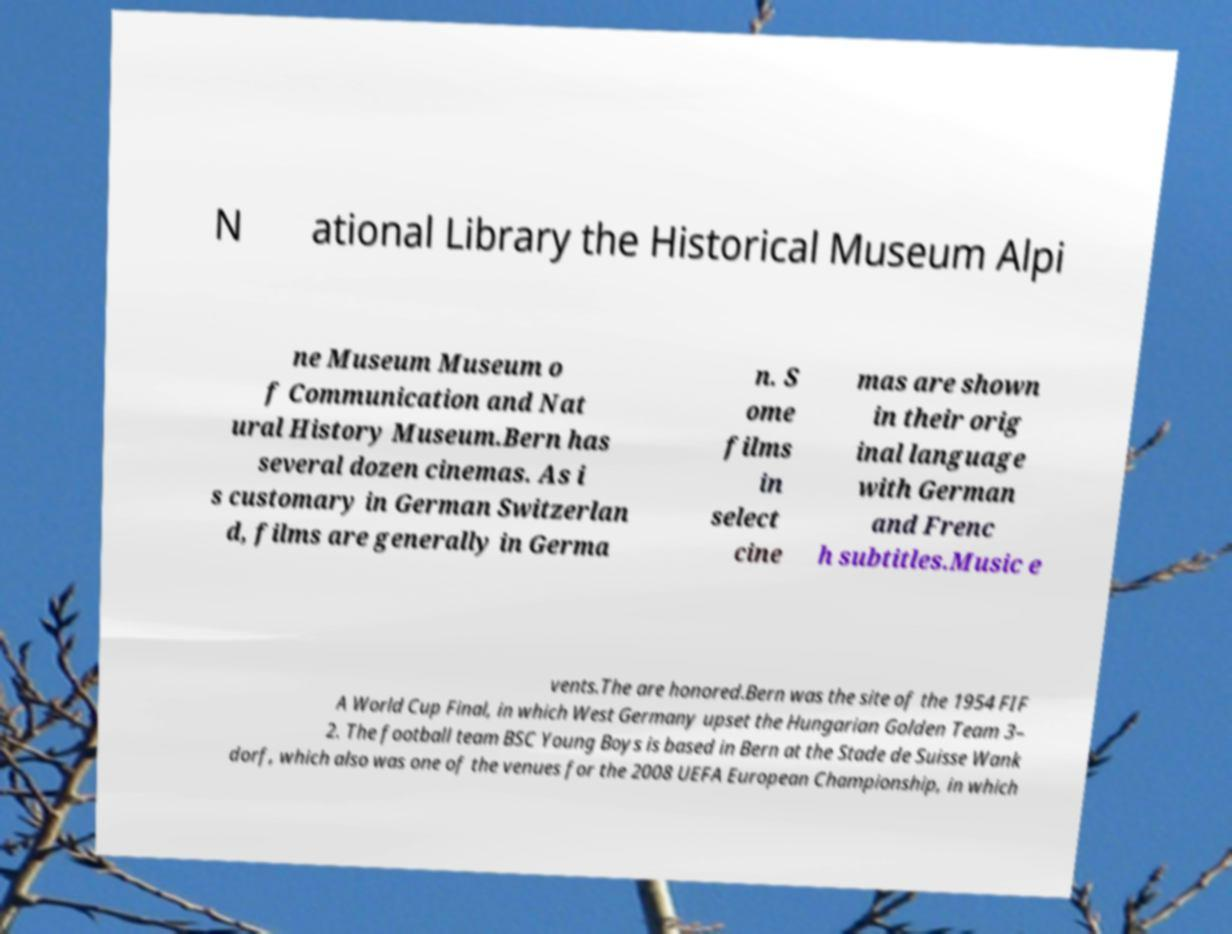Can you read and provide the text displayed in the image?This photo seems to have some interesting text. Can you extract and type it out for me? N ational Library the Historical Museum Alpi ne Museum Museum o f Communication and Nat ural History Museum.Bern has several dozen cinemas. As i s customary in German Switzerlan d, films are generally in Germa n. S ome films in select cine mas are shown in their orig inal language with German and Frenc h subtitles.Music e vents.The are honored.Bern was the site of the 1954 FIF A World Cup Final, in which West Germany upset the Hungarian Golden Team 3– 2. The football team BSC Young Boys is based in Bern at the Stade de Suisse Wank dorf, which also was one of the venues for the 2008 UEFA European Championship, in which 